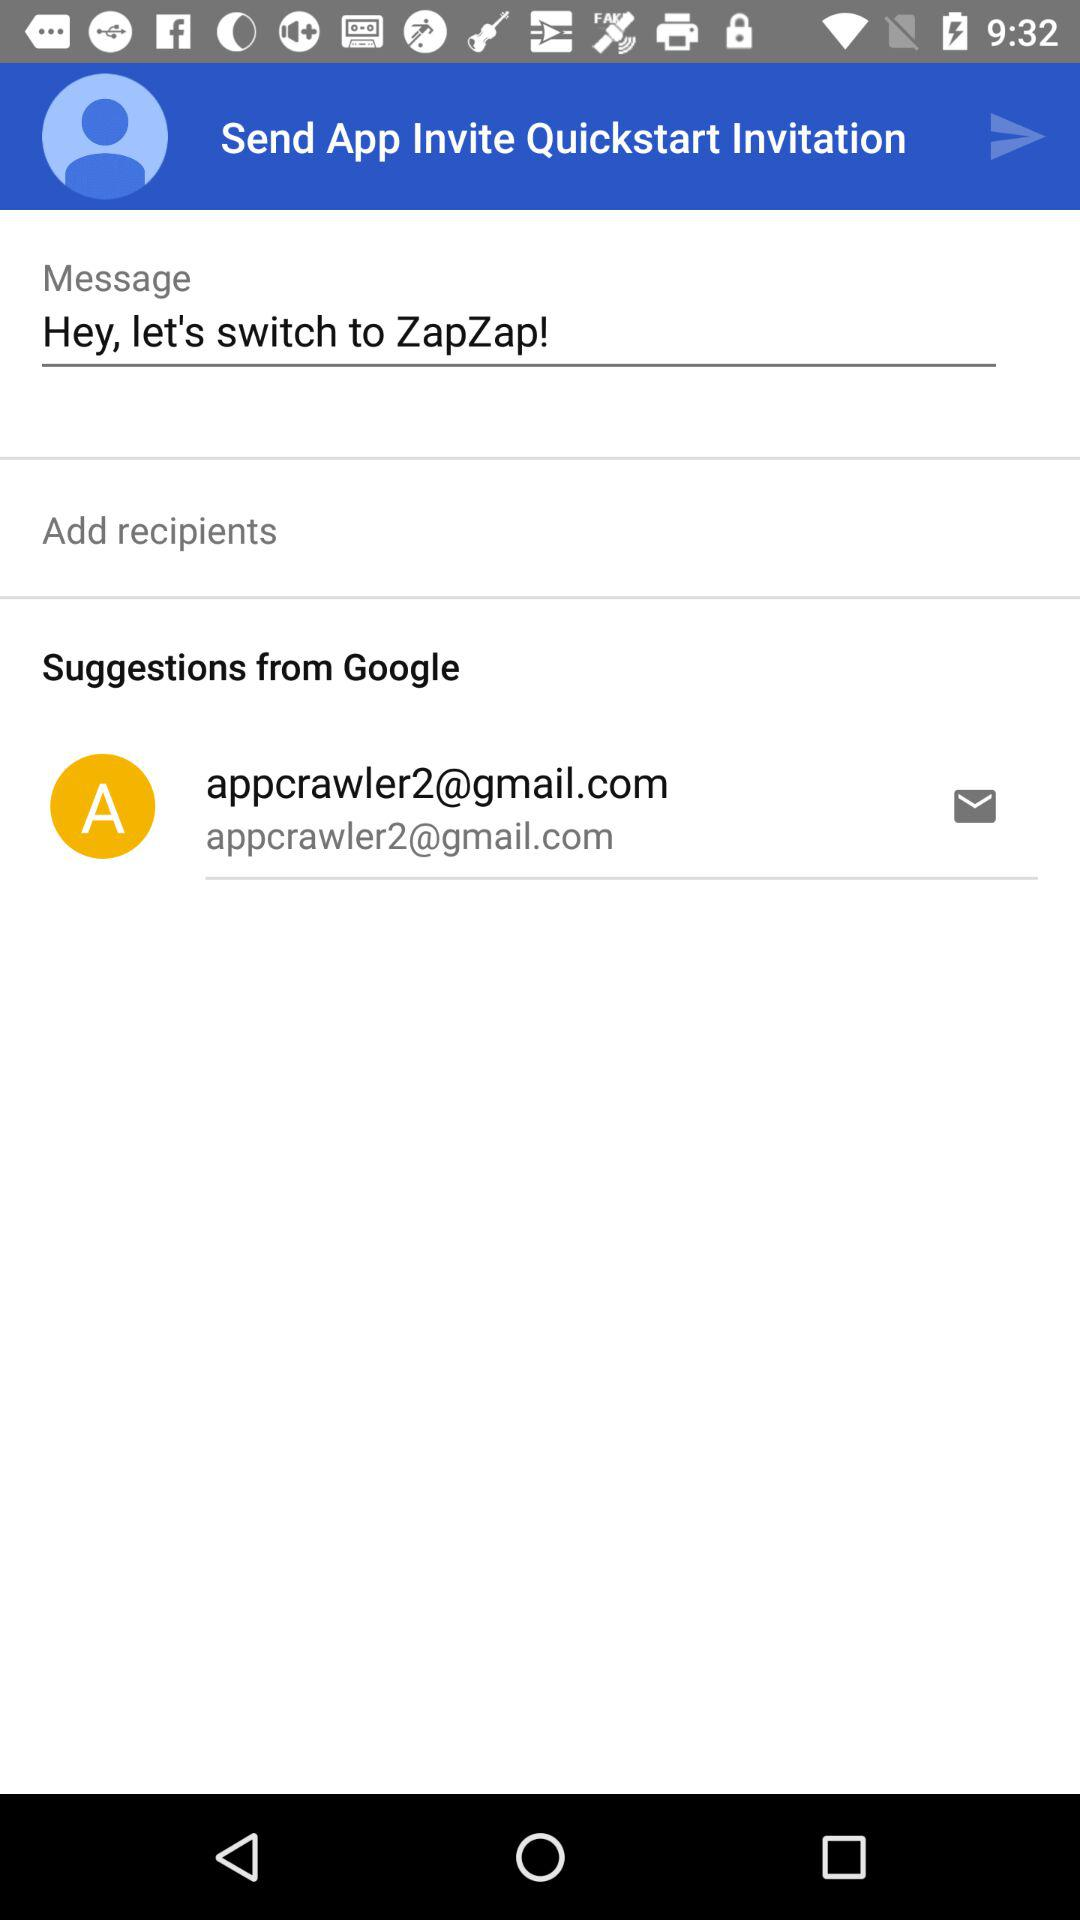What is the email address? The email address is appcrawler2@gmail.com. 